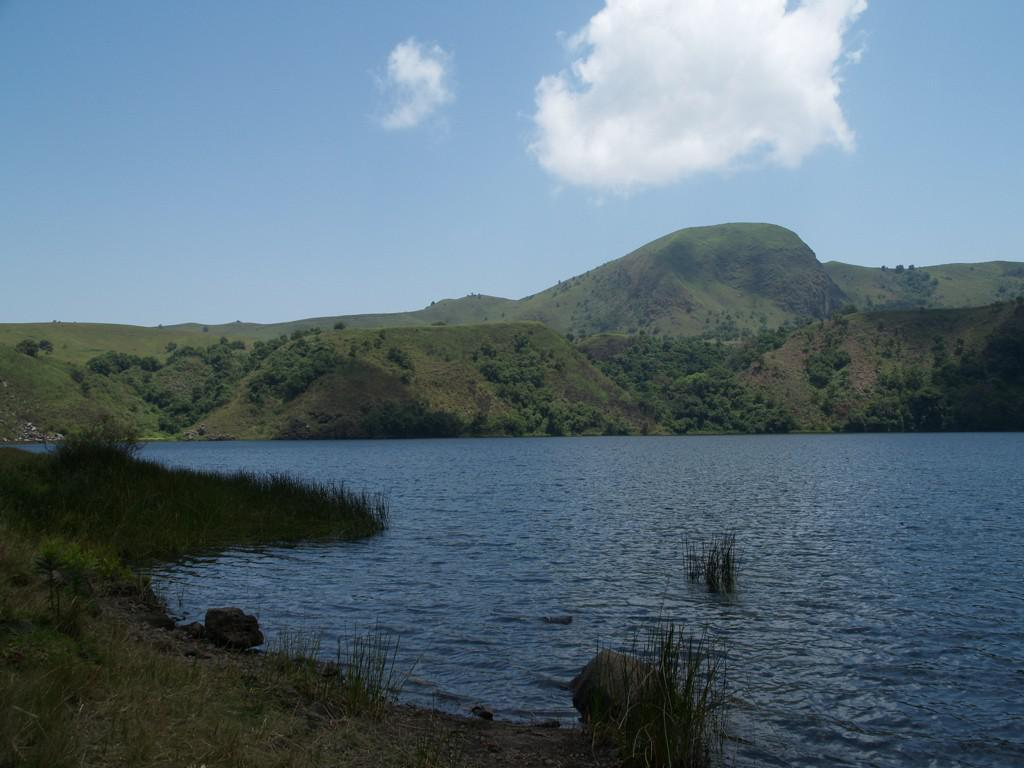What is the primary element visible in the image? There is water in the image. What type of vegetation can be seen at the bottom of the image? There is grass at the bottom of the image. What geographical features are visible in the background of the image? There are hills in the background of the image. What part of the natural environment is visible in the background of the image? The sky is visible in the background of the image. What type of fuel is being used by the boat in the image? There is no boat present in the image, so it is not possible to determine what type of fuel might be used. 